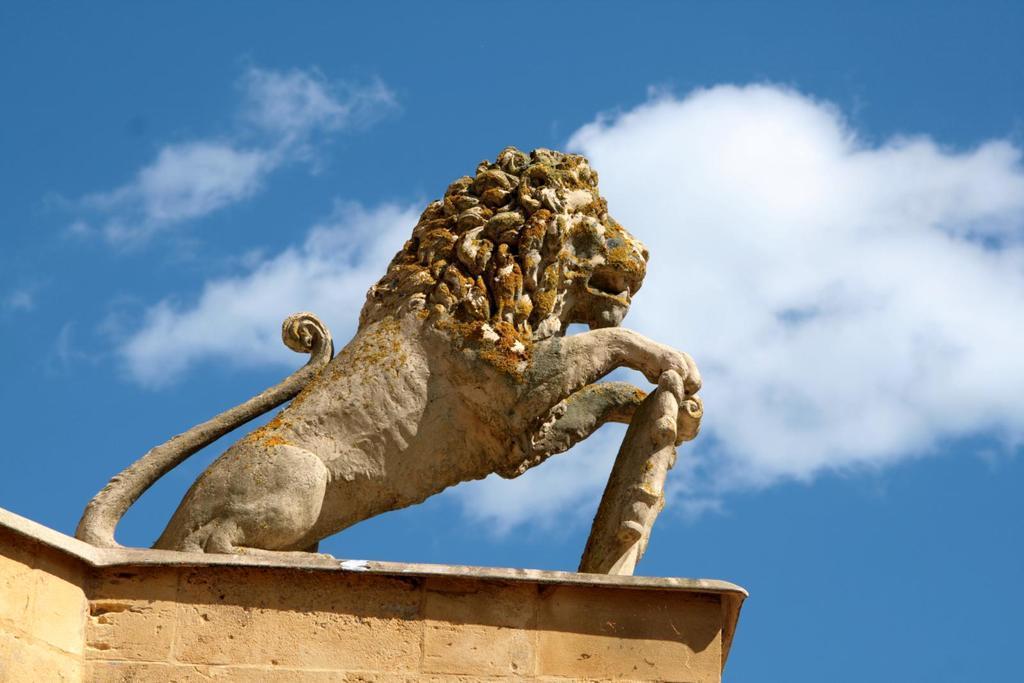Could you give a brief overview of what you see in this image? In the image there is a statue of a lion. 